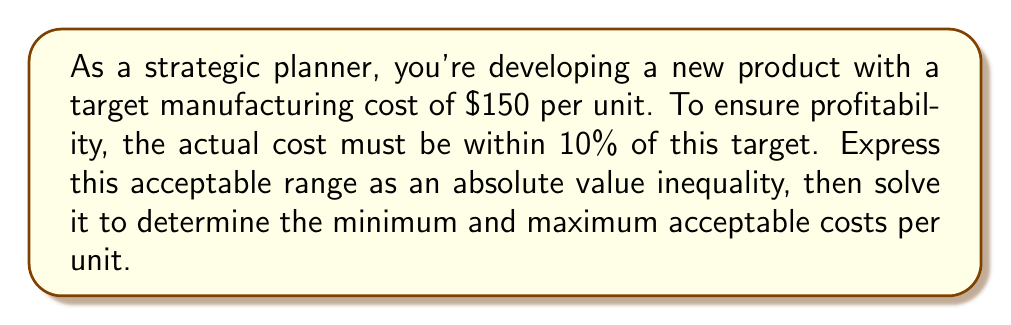What is the answer to this math problem? Let's approach this step-by-step:

1) Let $x$ represent the actual cost per unit.

2) We want $x$ to be within 10% of $150. This means the difference between $x$ and $150$ should be at most 10% of $150.

3) 10% of $150 is $150 \times 0.10 = 15$.

4) We can express this as an absolute value inequality:
   $$|x - 150| \leq 15$$

5) To solve this inequality, we need to consider two cases:
   Case 1: $x - 150 \leq 15$
   Case 2: $-(x - 150) \leq 15$ or $150 - x \leq 15$

6) Solving Case 1:
   $x - 150 \leq 15$
   $x \leq 165$

7) Solving Case 2:
   $150 - x \leq 15$
   $-x \leq -135$
   $x \geq 135$

8) Combining the results from both cases:
   $135 \leq x \leq 165$

Therefore, the minimum acceptable cost is $135 per unit, and the maximum acceptable cost is $165 per unit.
Answer: $135 \leq x \leq 165$, where $x$ is the cost per unit in dollars 